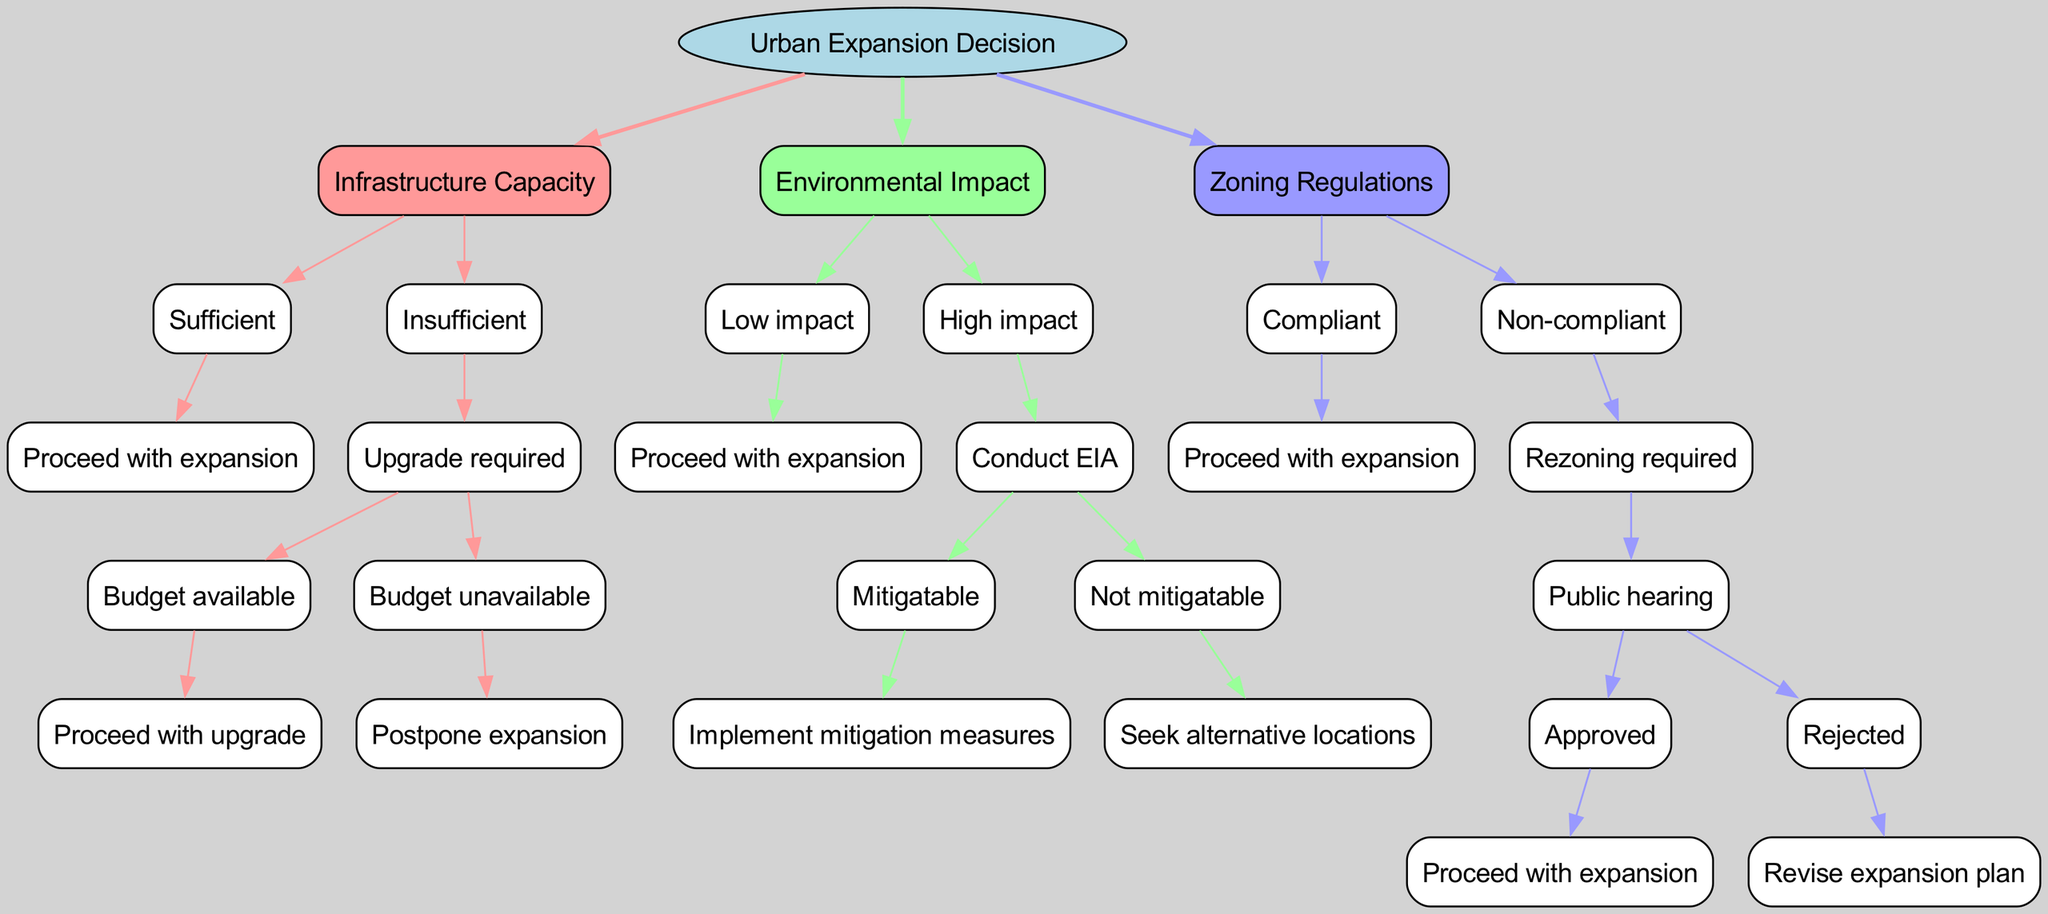What is the root node of the decision tree? The root node of the decision tree is labeled as "Urban Expansion Decision." This is the starting point from which all other decisions branch out.
Answer: Urban Expansion Decision How many main decision factors are present in the diagram? The diagram has three main decision factors: Infrastructure Capacity, Environmental Impact, and Zoning Regulations. Each of these factors branches out into further decisions.
Answer: 3 What happens if the infrastructure capacity is insufficient and the budget is unavailable? If the infrastructure capacity is insufficient, the next step involves checking for budget availability. If the budget is unavailable, the decision leads to "Postpone expansion."
Answer: Postpone expansion What are the outcomes if the environmental impact is low? If the environmental impact is low, the decision is straightforward, leading to "Proceed with expansion." There are no additional actions required in this case.
Answer: Proceed with expansion What should be done if zoning regulations are non-compliant but the public hearing is approved? If zoning regulations are non-compliant and the public hearing is approved, the outcome is to "Proceed with expansion." This indicates that the necessary approvals have been obtained to move forward.
Answer: Proceed with expansion What is the final decision if the environmental impact is high and not mitigatable? If the environmental impact is high and not mitigatable, the decision directs to "Seek alternative locations." This means that the expansion should not proceed at the current location due to the severe environmental impact.
Answer: Seek alternative locations What is required if zoning regulations are non-compliant? If zoning regulations are non-compliant, "Rezoning required" is necessary. This implies that the expansion plan needs to be revised according to zoning laws before proceeding.
Answer: Rezoning required What happens if the environmental impact is mitigatable? If the environmental impact is mitigatable, the decision flows to "Implement mitigation measures," indicating that steps can be taken to reduce the negative effects.
Answer: Implement mitigation measures 